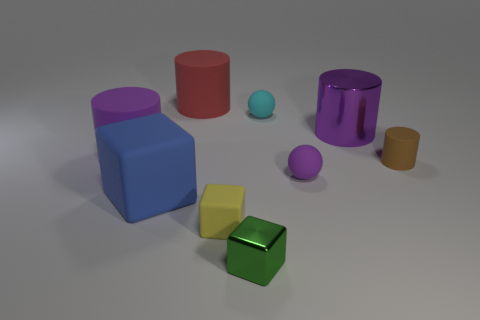Subtract all green cylinders. Subtract all blue blocks. How many cylinders are left? 4 Subtract all cylinders. How many objects are left? 5 Subtract all big cylinders. Subtract all brown rubber cubes. How many objects are left? 6 Add 3 small yellow rubber objects. How many small yellow rubber objects are left? 4 Add 4 small cylinders. How many small cylinders exist? 5 Subtract 1 green blocks. How many objects are left? 8 